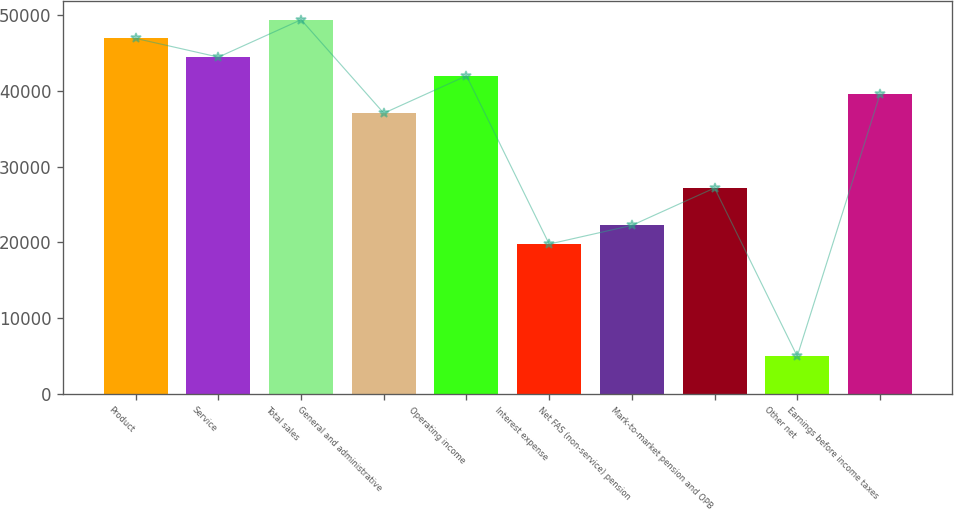Convert chart to OTSL. <chart><loc_0><loc_0><loc_500><loc_500><bar_chart><fcel>Product<fcel>Service<fcel>Total sales<fcel>General and administrative<fcel>Operating income<fcel>Interest expense<fcel>Net FAS (non-service) pension<fcel>Mark-to-market pension and OPB<fcel>Other net<fcel>Earnings before income taxes<nl><fcel>46931.2<fcel>44461.8<fcel>49400.7<fcel>37053.4<fcel>41992.3<fcel>19767.1<fcel>22236.5<fcel>27175.5<fcel>4950.26<fcel>39522.8<nl></chart> 